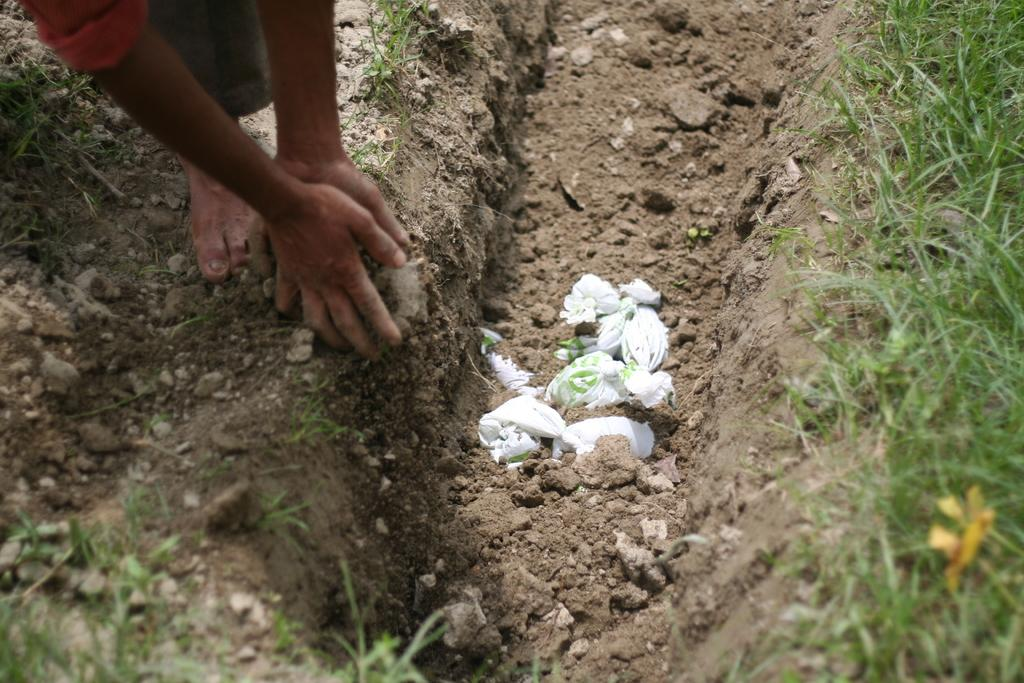What is the condition of the ground in the image? The ground in the image is dug. What can be found in the dug ground? There are items placed in the dug ground. Whose body parts are visible in the image? A person's hands and legs are visible in the image. What type of vegetation is present in the image? There is grass in the image. What type of wool is being exchanged between the person's hands in the image? There is no wool or exchange of any kind depicted in the image. 